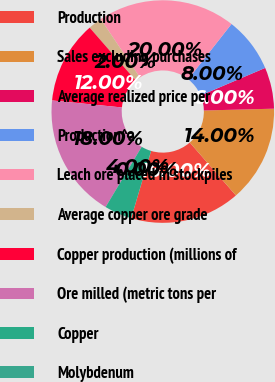Convert chart to OTSL. <chart><loc_0><loc_0><loc_500><loc_500><pie_chart><fcel>Production<fcel>Sales excluding purchases<fcel>Average realized price per<fcel>Production^a<fcel>Leach ore placed in stockpiles<fcel>Average copper ore grade<fcel>Copper production (millions of<fcel>Ore milled (metric tons per<fcel>Copper<fcel>Molybdenum<nl><fcel>16.0%<fcel>14.0%<fcel>6.0%<fcel>8.0%<fcel>20.0%<fcel>2.0%<fcel>12.0%<fcel>18.0%<fcel>4.0%<fcel>0.0%<nl></chart> 